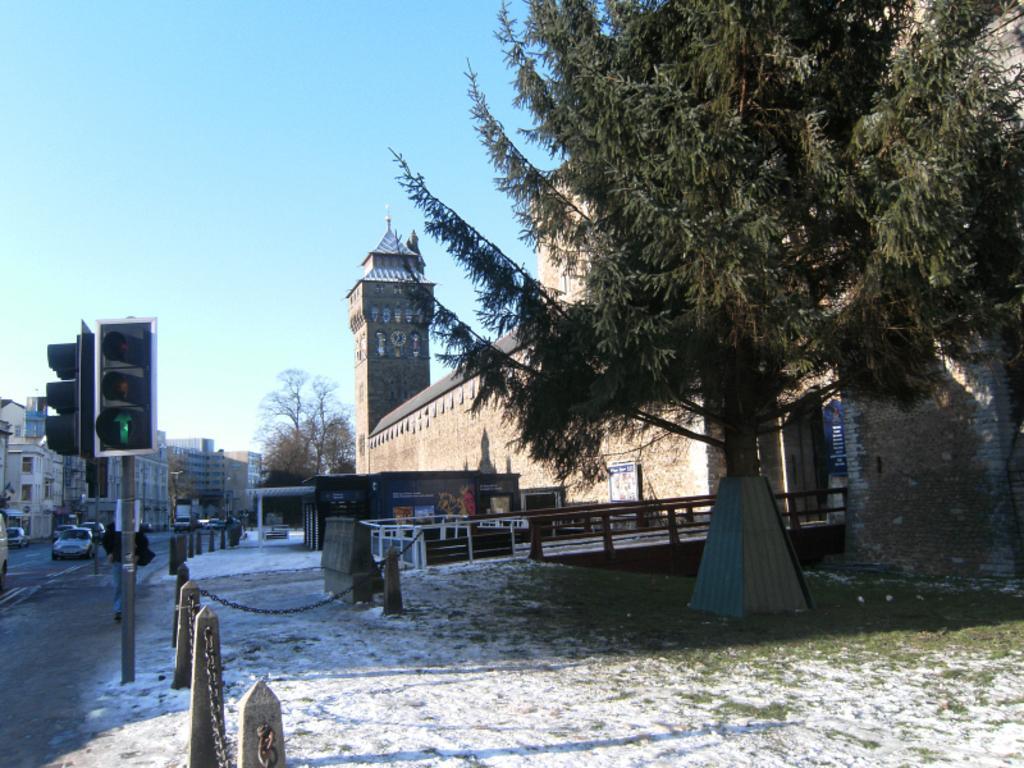Please provide a concise description of this image. At the bottom of the picture, we see the snow, grass and the barrier poles. On the right side, we see a tree and beside that, we see the iron railing. On the left side, we see the traffic signals and the vehicles are moving on the road. There are buildings, trees and a clock tower in the background. At the top, we see the sky. This picture is clicked outside the city. 